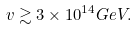Convert formula to latex. <formula><loc_0><loc_0><loc_500><loc_500>v \gtrsim 3 \times 1 0 ^ { 1 4 } G e V .</formula> 